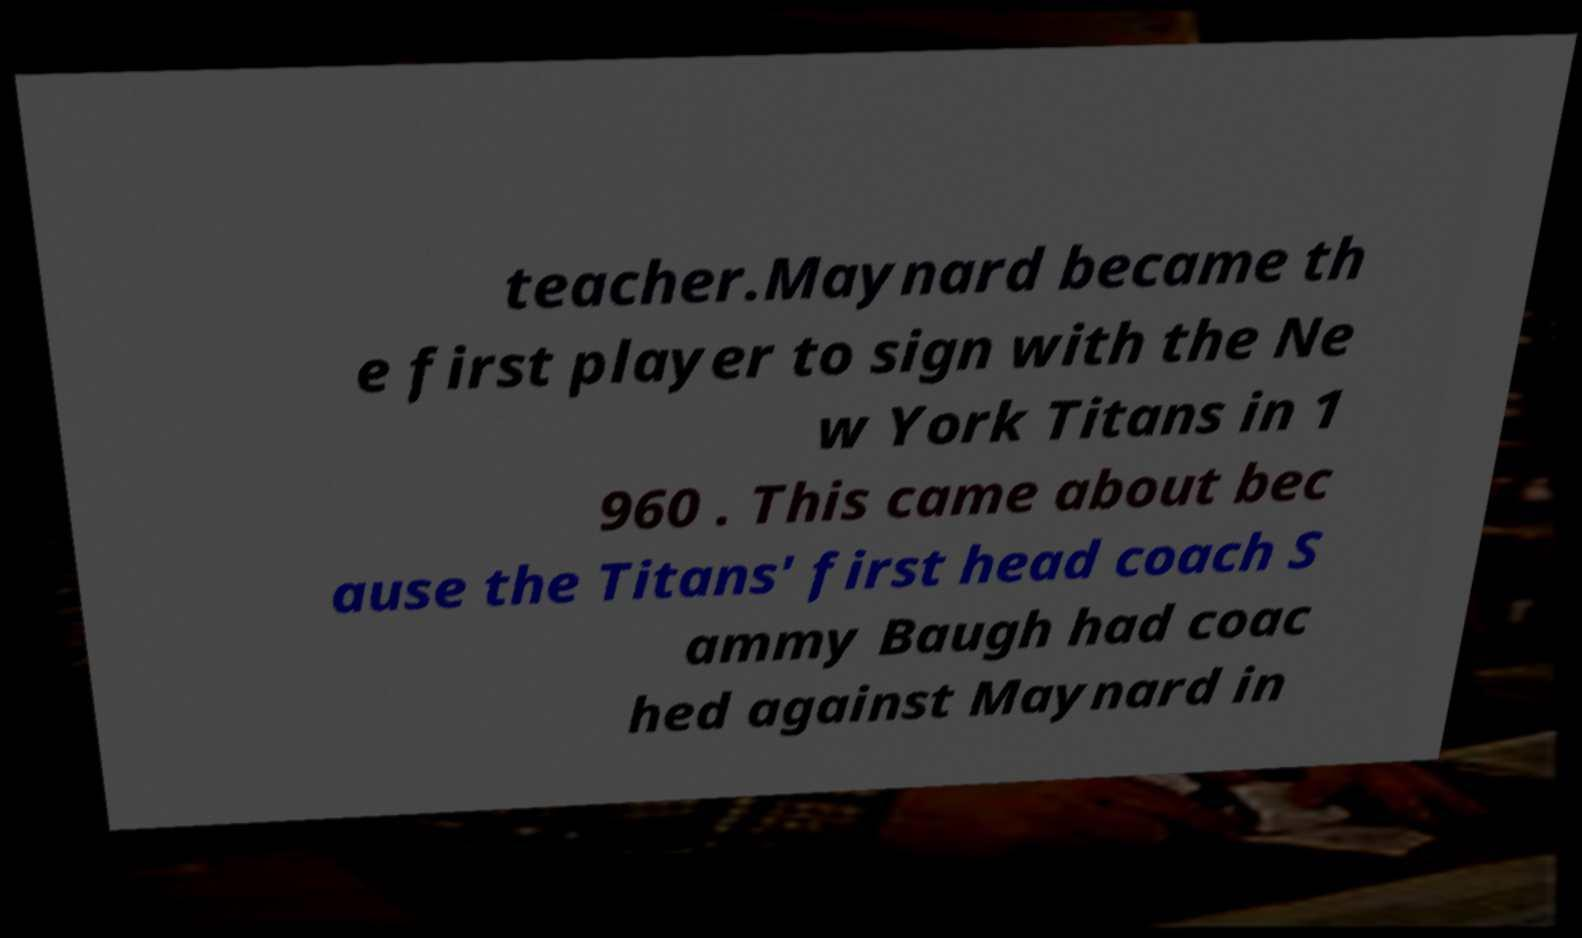I need the written content from this picture converted into text. Can you do that? teacher.Maynard became th e first player to sign with the Ne w York Titans in 1 960 . This came about bec ause the Titans' first head coach S ammy Baugh had coac hed against Maynard in 